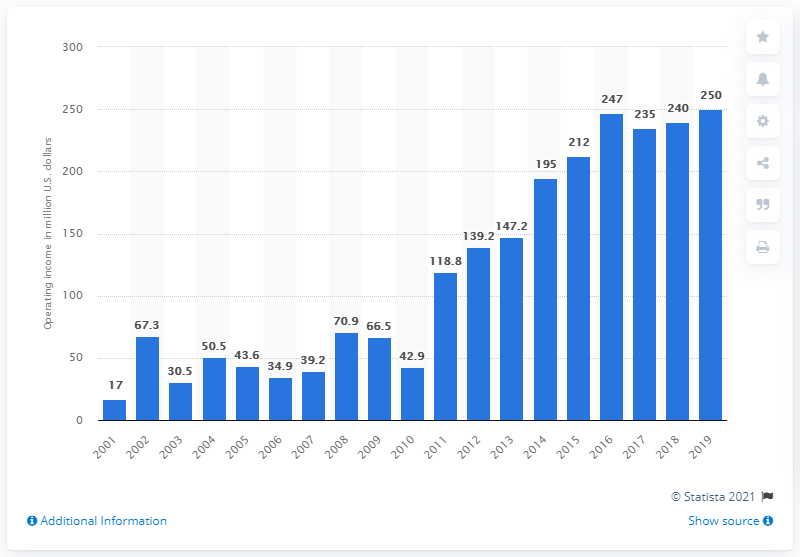List a handful of essential elements in this visual. The operating income of the New England Patriots during the 2019 season was 250 million dollars. 